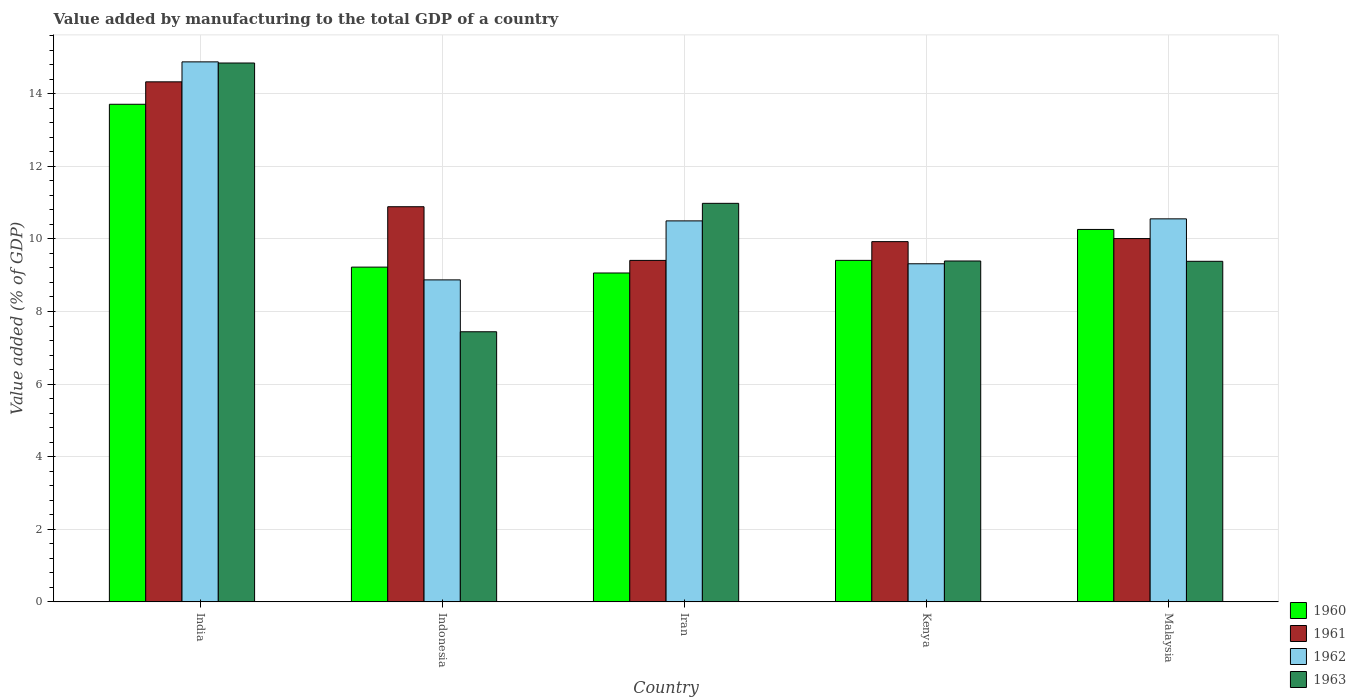How many groups of bars are there?
Offer a very short reply. 5. Are the number of bars on each tick of the X-axis equal?
Your answer should be very brief. Yes. How many bars are there on the 3rd tick from the right?
Ensure brevity in your answer.  4. What is the label of the 2nd group of bars from the left?
Offer a very short reply. Indonesia. In how many cases, is the number of bars for a given country not equal to the number of legend labels?
Offer a terse response. 0. What is the value added by manufacturing to the total GDP in 1961 in India?
Give a very brief answer. 14.33. Across all countries, what is the maximum value added by manufacturing to the total GDP in 1962?
Your answer should be very brief. 14.88. Across all countries, what is the minimum value added by manufacturing to the total GDP in 1961?
Offer a terse response. 9.41. In which country was the value added by manufacturing to the total GDP in 1960 minimum?
Your response must be concise. Iran. What is the total value added by manufacturing to the total GDP in 1961 in the graph?
Give a very brief answer. 54.56. What is the difference between the value added by manufacturing to the total GDP in 1962 in Kenya and that in Malaysia?
Provide a succinct answer. -1.24. What is the difference between the value added by manufacturing to the total GDP in 1962 in India and the value added by manufacturing to the total GDP in 1963 in Indonesia?
Provide a short and direct response. 7.44. What is the average value added by manufacturing to the total GDP in 1962 per country?
Give a very brief answer. 10.82. What is the difference between the value added by manufacturing to the total GDP of/in 1962 and value added by manufacturing to the total GDP of/in 1961 in India?
Offer a terse response. 0.55. What is the ratio of the value added by manufacturing to the total GDP in 1960 in India to that in Iran?
Ensure brevity in your answer.  1.51. Is the difference between the value added by manufacturing to the total GDP in 1962 in Indonesia and Malaysia greater than the difference between the value added by manufacturing to the total GDP in 1961 in Indonesia and Malaysia?
Make the answer very short. No. What is the difference between the highest and the second highest value added by manufacturing to the total GDP in 1960?
Ensure brevity in your answer.  -0.85. What is the difference between the highest and the lowest value added by manufacturing to the total GDP in 1962?
Ensure brevity in your answer.  6.01. In how many countries, is the value added by manufacturing to the total GDP in 1963 greater than the average value added by manufacturing to the total GDP in 1963 taken over all countries?
Offer a terse response. 2. What does the 1st bar from the left in Kenya represents?
Provide a succinct answer. 1960. Is it the case that in every country, the sum of the value added by manufacturing to the total GDP in 1962 and value added by manufacturing to the total GDP in 1963 is greater than the value added by manufacturing to the total GDP in 1961?
Offer a very short reply. Yes. How many bars are there?
Provide a short and direct response. 20. Are the values on the major ticks of Y-axis written in scientific E-notation?
Keep it short and to the point. No. How many legend labels are there?
Make the answer very short. 4. How are the legend labels stacked?
Your answer should be very brief. Vertical. What is the title of the graph?
Ensure brevity in your answer.  Value added by manufacturing to the total GDP of a country. What is the label or title of the Y-axis?
Give a very brief answer. Value added (% of GDP). What is the Value added (% of GDP) in 1960 in India?
Ensure brevity in your answer.  13.71. What is the Value added (% of GDP) in 1961 in India?
Your answer should be very brief. 14.33. What is the Value added (% of GDP) of 1962 in India?
Your answer should be compact. 14.88. What is the Value added (% of GDP) of 1963 in India?
Your answer should be very brief. 14.85. What is the Value added (% of GDP) in 1960 in Indonesia?
Ensure brevity in your answer.  9.22. What is the Value added (% of GDP) of 1961 in Indonesia?
Provide a succinct answer. 10.89. What is the Value added (% of GDP) in 1962 in Indonesia?
Offer a very short reply. 8.87. What is the Value added (% of GDP) in 1963 in Indonesia?
Ensure brevity in your answer.  7.44. What is the Value added (% of GDP) in 1960 in Iran?
Keep it short and to the point. 9.06. What is the Value added (% of GDP) of 1961 in Iran?
Your answer should be very brief. 9.41. What is the Value added (% of GDP) of 1962 in Iran?
Your answer should be compact. 10.5. What is the Value added (% of GDP) in 1963 in Iran?
Provide a short and direct response. 10.98. What is the Value added (% of GDP) in 1960 in Kenya?
Offer a terse response. 9.41. What is the Value added (% of GDP) of 1961 in Kenya?
Keep it short and to the point. 9.93. What is the Value added (% of GDP) of 1962 in Kenya?
Offer a terse response. 9.32. What is the Value added (% of GDP) of 1963 in Kenya?
Provide a short and direct response. 9.39. What is the Value added (% of GDP) in 1960 in Malaysia?
Provide a succinct answer. 10.26. What is the Value added (% of GDP) in 1961 in Malaysia?
Provide a short and direct response. 10.01. What is the Value added (% of GDP) in 1962 in Malaysia?
Provide a short and direct response. 10.55. What is the Value added (% of GDP) of 1963 in Malaysia?
Provide a short and direct response. 9.38. Across all countries, what is the maximum Value added (% of GDP) in 1960?
Make the answer very short. 13.71. Across all countries, what is the maximum Value added (% of GDP) in 1961?
Keep it short and to the point. 14.33. Across all countries, what is the maximum Value added (% of GDP) in 1962?
Make the answer very short. 14.88. Across all countries, what is the maximum Value added (% of GDP) in 1963?
Provide a succinct answer. 14.85. Across all countries, what is the minimum Value added (% of GDP) in 1960?
Your answer should be very brief. 9.06. Across all countries, what is the minimum Value added (% of GDP) in 1961?
Your answer should be very brief. 9.41. Across all countries, what is the minimum Value added (% of GDP) of 1962?
Your answer should be very brief. 8.87. Across all countries, what is the minimum Value added (% of GDP) in 1963?
Ensure brevity in your answer.  7.44. What is the total Value added (% of GDP) in 1960 in the graph?
Your answer should be compact. 51.66. What is the total Value added (% of GDP) in 1961 in the graph?
Your answer should be very brief. 54.56. What is the total Value added (% of GDP) of 1962 in the graph?
Offer a very short reply. 54.11. What is the total Value added (% of GDP) in 1963 in the graph?
Ensure brevity in your answer.  52.04. What is the difference between the Value added (% of GDP) of 1960 in India and that in Indonesia?
Ensure brevity in your answer.  4.49. What is the difference between the Value added (% of GDP) of 1961 in India and that in Indonesia?
Your response must be concise. 3.44. What is the difference between the Value added (% of GDP) of 1962 in India and that in Indonesia?
Provide a short and direct response. 6.01. What is the difference between the Value added (% of GDP) in 1963 in India and that in Indonesia?
Offer a terse response. 7.4. What is the difference between the Value added (% of GDP) in 1960 in India and that in Iran?
Your answer should be very brief. 4.65. What is the difference between the Value added (% of GDP) in 1961 in India and that in Iran?
Your answer should be compact. 4.92. What is the difference between the Value added (% of GDP) in 1962 in India and that in Iran?
Provide a short and direct response. 4.38. What is the difference between the Value added (% of GDP) in 1963 in India and that in Iran?
Ensure brevity in your answer.  3.87. What is the difference between the Value added (% of GDP) of 1960 in India and that in Kenya?
Give a very brief answer. 4.3. What is the difference between the Value added (% of GDP) in 1961 in India and that in Kenya?
Offer a very short reply. 4.4. What is the difference between the Value added (% of GDP) in 1962 in India and that in Kenya?
Your answer should be compact. 5.56. What is the difference between the Value added (% of GDP) of 1963 in India and that in Kenya?
Provide a succinct answer. 5.45. What is the difference between the Value added (% of GDP) in 1960 in India and that in Malaysia?
Make the answer very short. 3.45. What is the difference between the Value added (% of GDP) of 1961 in India and that in Malaysia?
Make the answer very short. 4.32. What is the difference between the Value added (% of GDP) in 1962 in India and that in Malaysia?
Make the answer very short. 4.33. What is the difference between the Value added (% of GDP) in 1963 in India and that in Malaysia?
Your answer should be very brief. 5.46. What is the difference between the Value added (% of GDP) of 1960 in Indonesia and that in Iran?
Offer a very short reply. 0.16. What is the difference between the Value added (% of GDP) in 1961 in Indonesia and that in Iran?
Offer a very short reply. 1.48. What is the difference between the Value added (% of GDP) in 1962 in Indonesia and that in Iran?
Your answer should be very brief. -1.63. What is the difference between the Value added (% of GDP) of 1963 in Indonesia and that in Iran?
Keep it short and to the point. -3.54. What is the difference between the Value added (% of GDP) in 1960 in Indonesia and that in Kenya?
Offer a terse response. -0.19. What is the difference between the Value added (% of GDP) of 1961 in Indonesia and that in Kenya?
Offer a terse response. 0.96. What is the difference between the Value added (% of GDP) of 1962 in Indonesia and that in Kenya?
Make the answer very short. -0.44. What is the difference between the Value added (% of GDP) in 1963 in Indonesia and that in Kenya?
Make the answer very short. -1.95. What is the difference between the Value added (% of GDP) in 1960 in Indonesia and that in Malaysia?
Give a very brief answer. -1.04. What is the difference between the Value added (% of GDP) of 1961 in Indonesia and that in Malaysia?
Your answer should be very brief. 0.88. What is the difference between the Value added (% of GDP) of 1962 in Indonesia and that in Malaysia?
Offer a very short reply. -1.68. What is the difference between the Value added (% of GDP) in 1963 in Indonesia and that in Malaysia?
Provide a short and direct response. -1.94. What is the difference between the Value added (% of GDP) of 1960 in Iran and that in Kenya?
Offer a very short reply. -0.35. What is the difference between the Value added (% of GDP) of 1961 in Iran and that in Kenya?
Your answer should be very brief. -0.52. What is the difference between the Value added (% of GDP) of 1962 in Iran and that in Kenya?
Keep it short and to the point. 1.18. What is the difference between the Value added (% of GDP) of 1963 in Iran and that in Kenya?
Offer a terse response. 1.59. What is the difference between the Value added (% of GDP) in 1960 in Iran and that in Malaysia?
Offer a very short reply. -1.2. What is the difference between the Value added (% of GDP) of 1961 in Iran and that in Malaysia?
Your answer should be very brief. -0.6. What is the difference between the Value added (% of GDP) of 1962 in Iran and that in Malaysia?
Provide a short and direct response. -0.06. What is the difference between the Value added (% of GDP) of 1963 in Iran and that in Malaysia?
Provide a succinct answer. 1.6. What is the difference between the Value added (% of GDP) in 1960 in Kenya and that in Malaysia?
Provide a short and direct response. -0.85. What is the difference between the Value added (% of GDP) of 1961 in Kenya and that in Malaysia?
Provide a short and direct response. -0.08. What is the difference between the Value added (% of GDP) of 1962 in Kenya and that in Malaysia?
Your response must be concise. -1.24. What is the difference between the Value added (% of GDP) of 1963 in Kenya and that in Malaysia?
Ensure brevity in your answer.  0.01. What is the difference between the Value added (% of GDP) in 1960 in India and the Value added (% of GDP) in 1961 in Indonesia?
Offer a terse response. 2.82. What is the difference between the Value added (% of GDP) of 1960 in India and the Value added (% of GDP) of 1962 in Indonesia?
Make the answer very short. 4.84. What is the difference between the Value added (% of GDP) in 1960 in India and the Value added (% of GDP) in 1963 in Indonesia?
Your response must be concise. 6.27. What is the difference between the Value added (% of GDP) in 1961 in India and the Value added (% of GDP) in 1962 in Indonesia?
Provide a short and direct response. 5.46. What is the difference between the Value added (% of GDP) in 1961 in India and the Value added (% of GDP) in 1963 in Indonesia?
Keep it short and to the point. 6.89. What is the difference between the Value added (% of GDP) in 1962 in India and the Value added (% of GDP) in 1963 in Indonesia?
Make the answer very short. 7.44. What is the difference between the Value added (% of GDP) of 1960 in India and the Value added (% of GDP) of 1961 in Iran?
Provide a short and direct response. 4.3. What is the difference between the Value added (% of GDP) in 1960 in India and the Value added (% of GDP) in 1962 in Iran?
Your answer should be very brief. 3.21. What is the difference between the Value added (% of GDP) of 1960 in India and the Value added (% of GDP) of 1963 in Iran?
Ensure brevity in your answer.  2.73. What is the difference between the Value added (% of GDP) in 1961 in India and the Value added (% of GDP) in 1962 in Iran?
Make the answer very short. 3.83. What is the difference between the Value added (% of GDP) in 1961 in India and the Value added (% of GDP) in 1963 in Iran?
Offer a very short reply. 3.35. What is the difference between the Value added (% of GDP) in 1962 in India and the Value added (% of GDP) in 1963 in Iran?
Keep it short and to the point. 3.9. What is the difference between the Value added (% of GDP) of 1960 in India and the Value added (% of GDP) of 1961 in Kenya?
Offer a very short reply. 3.78. What is the difference between the Value added (% of GDP) in 1960 in India and the Value added (% of GDP) in 1962 in Kenya?
Keep it short and to the point. 4.39. What is the difference between the Value added (% of GDP) of 1960 in India and the Value added (% of GDP) of 1963 in Kenya?
Your answer should be very brief. 4.32. What is the difference between the Value added (% of GDP) of 1961 in India and the Value added (% of GDP) of 1962 in Kenya?
Provide a short and direct response. 5.01. What is the difference between the Value added (% of GDP) of 1961 in India and the Value added (% of GDP) of 1963 in Kenya?
Provide a succinct answer. 4.94. What is the difference between the Value added (% of GDP) of 1962 in India and the Value added (% of GDP) of 1963 in Kenya?
Provide a short and direct response. 5.49. What is the difference between the Value added (% of GDP) in 1960 in India and the Value added (% of GDP) in 1961 in Malaysia?
Offer a very short reply. 3.7. What is the difference between the Value added (% of GDP) in 1960 in India and the Value added (% of GDP) in 1962 in Malaysia?
Provide a succinct answer. 3.16. What is the difference between the Value added (% of GDP) of 1960 in India and the Value added (% of GDP) of 1963 in Malaysia?
Your response must be concise. 4.33. What is the difference between the Value added (% of GDP) in 1961 in India and the Value added (% of GDP) in 1962 in Malaysia?
Keep it short and to the point. 3.78. What is the difference between the Value added (% of GDP) of 1961 in India and the Value added (% of GDP) of 1963 in Malaysia?
Keep it short and to the point. 4.94. What is the difference between the Value added (% of GDP) of 1962 in India and the Value added (% of GDP) of 1963 in Malaysia?
Offer a terse response. 5.49. What is the difference between the Value added (% of GDP) of 1960 in Indonesia and the Value added (% of GDP) of 1961 in Iran?
Your response must be concise. -0.18. What is the difference between the Value added (% of GDP) in 1960 in Indonesia and the Value added (% of GDP) in 1962 in Iran?
Ensure brevity in your answer.  -1.27. What is the difference between the Value added (% of GDP) in 1960 in Indonesia and the Value added (% of GDP) in 1963 in Iran?
Your answer should be compact. -1.76. What is the difference between the Value added (% of GDP) of 1961 in Indonesia and the Value added (% of GDP) of 1962 in Iran?
Keep it short and to the point. 0.39. What is the difference between the Value added (% of GDP) of 1961 in Indonesia and the Value added (% of GDP) of 1963 in Iran?
Offer a terse response. -0.09. What is the difference between the Value added (% of GDP) in 1962 in Indonesia and the Value added (% of GDP) in 1963 in Iran?
Provide a succinct answer. -2.11. What is the difference between the Value added (% of GDP) in 1960 in Indonesia and the Value added (% of GDP) in 1961 in Kenya?
Give a very brief answer. -0.7. What is the difference between the Value added (% of GDP) of 1960 in Indonesia and the Value added (% of GDP) of 1962 in Kenya?
Your response must be concise. -0.09. What is the difference between the Value added (% of GDP) in 1960 in Indonesia and the Value added (% of GDP) in 1963 in Kenya?
Your answer should be very brief. -0.17. What is the difference between the Value added (% of GDP) of 1961 in Indonesia and the Value added (% of GDP) of 1962 in Kenya?
Offer a terse response. 1.57. What is the difference between the Value added (% of GDP) in 1961 in Indonesia and the Value added (% of GDP) in 1963 in Kenya?
Make the answer very short. 1.5. What is the difference between the Value added (% of GDP) in 1962 in Indonesia and the Value added (% of GDP) in 1963 in Kenya?
Provide a succinct answer. -0.52. What is the difference between the Value added (% of GDP) in 1960 in Indonesia and the Value added (% of GDP) in 1961 in Malaysia?
Keep it short and to the point. -0.79. What is the difference between the Value added (% of GDP) of 1960 in Indonesia and the Value added (% of GDP) of 1962 in Malaysia?
Give a very brief answer. -1.33. What is the difference between the Value added (% of GDP) in 1960 in Indonesia and the Value added (% of GDP) in 1963 in Malaysia?
Offer a very short reply. -0.16. What is the difference between the Value added (% of GDP) in 1961 in Indonesia and the Value added (% of GDP) in 1962 in Malaysia?
Provide a succinct answer. 0.33. What is the difference between the Value added (% of GDP) of 1961 in Indonesia and the Value added (% of GDP) of 1963 in Malaysia?
Offer a terse response. 1.5. What is the difference between the Value added (% of GDP) in 1962 in Indonesia and the Value added (% of GDP) in 1963 in Malaysia?
Offer a terse response. -0.51. What is the difference between the Value added (% of GDP) in 1960 in Iran and the Value added (% of GDP) in 1961 in Kenya?
Provide a succinct answer. -0.86. What is the difference between the Value added (% of GDP) of 1960 in Iran and the Value added (% of GDP) of 1962 in Kenya?
Keep it short and to the point. -0.25. What is the difference between the Value added (% of GDP) of 1960 in Iran and the Value added (% of GDP) of 1963 in Kenya?
Offer a terse response. -0.33. What is the difference between the Value added (% of GDP) of 1961 in Iran and the Value added (% of GDP) of 1962 in Kenya?
Offer a very short reply. 0.09. What is the difference between the Value added (% of GDP) of 1961 in Iran and the Value added (% of GDP) of 1963 in Kenya?
Your response must be concise. 0.02. What is the difference between the Value added (% of GDP) of 1962 in Iran and the Value added (% of GDP) of 1963 in Kenya?
Your answer should be very brief. 1.11. What is the difference between the Value added (% of GDP) in 1960 in Iran and the Value added (% of GDP) in 1961 in Malaysia?
Provide a succinct answer. -0.95. What is the difference between the Value added (% of GDP) of 1960 in Iran and the Value added (% of GDP) of 1962 in Malaysia?
Offer a very short reply. -1.49. What is the difference between the Value added (% of GDP) of 1960 in Iran and the Value added (% of GDP) of 1963 in Malaysia?
Give a very brief answer. -0.32. What is the difference between the Value added (% of GDP) of 1961 in Iran and the Value added (% of GDP) of 1962 in Malaysia?
Your answer should be very brief. -1.14. What is the difference between the Value added (% of GDP) of 1961 in Iran and the Value added (% of GDP) of 1963 in Malaysia?
Give a very brief answer. 0.03. What is the difference between the Value added (% of GDP) in 1962 in Iran and the Value added (% of GDP) in 1963 in Malaysia?
Make the answer very short. 1.11. What is the difference between the Value added (% of GDP) of 1960 in Kenya and the Value added (% of GDP) of 1961 in Malaysia?
Make the answer very short. -0.6. What is the difference between the Value added (% of GDP) in 1960 in Kenya and the Value added (% of GDP) in 1962 in Malaysia?
Your answer should be compact. -1.14. What is the difference between the Value added (% of GDP) of 1960 in Kenya and the Value added (% of GDP) of 1963 in Malaysia?
Make the answer very short. 0.03. What is the difference between the Value added (% of GDP) of 1961 in Kenya and the Value added (% of GDP) of 1962 in Malaysia?
Offer a terse response. -0.63. What is the difference between the Value added (% of GDP) of 1961 in Kenya and the Value added (% of GDP) of 1963 in Malaysia?
Give a very brief answer. 0.54. What is the difference between the Value added (% of GDP) of 1962 in Kenya and the Value added (% of GDP) of 1963 in Malaysia?
Offer a very short reply. -0.07. What is the average Value added (% of GDP) in 1960 per country?
Provide a succinct answer. 10.33. What is the average Value added (% of GDP) of 1961 per country?
Make the answer very short. 10.91. What is the average Value added (% of GDP) in 1962 per country?
Provide a short and direct response. 10.82. What is the average Value added (% of GDP) of 1963 per country?
Make the answer very short. 10.41. What is the difference between the Value added (% of GDP) in 1960 and Value added (% of GDP) in 1961 in India?
Ensure brevity in your answer.  -0.62. What is the difference between the Value added (% of GDP) of 1960 and Value added (% of GDP) of 1962 in India?
Make the answer very short. -1.17. What is the difference between the Value added (% of GDP) in 1960 and Value added (% of GDP) in 1963 in India?
Provide a short and direct response. -1.14. What is the difference between the Value added (% of GDP) of 1961 and Value added (% of GDP) of 1962 in India?
Offer a terse response. -0.55. What is the difference between the Value added (% of GDP) in 1961 and Value added (% of GDP) in 1963 in India?
Your answer should be very brief. -0.52. What is the difference between the Value added (% of GDP) in 1962 and Value added (% of GDP) in 1963 in India?
Your answer should be compact. 0.03. What is the difference between the Value added (% of GDP) in 1960 and Value added (% of GDP) in 1961 in Indonesia?
Offer a very short reply. -1.66. What is the difference between the Value added (% of GDP) of 1960 and Value added (% of GDP) of 1962 in Indonesia?
Provide a succinct answer. 0.35. What is the difference between the Value added (% of GDP) of 1960 and Value added (% of GDP) of 1963 in Indonesia?
Make the answer very short. 1.78. What is the difference between the Value added (% of GDP) in 1961 and Value added (% of GDP) in 1962 in Indonesia?
Provide a succinct answer. 2.02. What is the difference between the Value added (% of GDP) in 1961 and Value added (% of GDP) in 1963 in Indonesia?
Your answer should be compact. 3.44. What is the difference between the Value added (% of GDP) in 1962 and Value added (% of GDP) in 1963 in Indonesia?
Keep it short and to the point. 1.43. What is the difference between the Value added (% of GDP) of 1960 and Value added (% of GDP) of 1961 in Iran?
Your answer should be very brief. -0.35. What is the difference between the Value added (% of GDP) of 1960 and Value added (% of GDP) of 1962 in Iran?
Your response must be concise. -1.44. What is the difference between the Value added (% of GDP) in 1960 and Value added (% of GDP) in 1963 in Iran?
Your answer should be compact. -1.92. What is the difference between the Value added (% of GDP) of 1961 and Value added (% of GDP) of 1962 in Iran?
Your response must be concise. -1.09. What is the difference between the Value added (% of GDP) in 1961 and Value added (% of GDP) in 1963 in Iran?
Ensure brevity in your answer.  -1.57. What is the difference between the Value added (% of GDP) of 1962 and Value added (% of GDP) of 1963 in Iran?
Offer a very short reply. -0.48. What is the difference between the Value added (% of GDP) of 1960 and Value added (% of GDP) of 1961 in Kenya?
Provide a succinct answer. -0.52. What is the difference between the Value added (% of GDP) in 1960 and Value added (% of GDP) in 1962 in Kenya?
Keep it short and to the point. 0.09. What is the difference between the Value added (% of GDP) in 1960 and Value added (% of GDP) in 1963 in Kenya?
Provide a short and direct response. 0.02. What is the difference between the Value added (% of GDP) of 1961 and Value added (% of GDP) of 1962 in Kenya?
Your response must be concise. 0.61. What is the difference between the Value added (% of GDP) of 1961 and Value added (% of GDP) of 1963 in Kenya?
Give a very brief answer. 0.53. What is the difference between the Value added (% of GDP) of 1962 and Value added (% of GDP) of 1963 in Kenya?
Provide a succinct answer. -0.08. What is the difference between the Value added (% of GDP) of 1960 and Value added (% of GDP) of 1961 in Malaysia?
Your answer should be very brief. 0.25. What is the difference between the Value added (% of GDP) of 1960 and Value added (% of GDP) of 1962 in Malaysia?
Your answer should be compact. -0.29. What is the difference between the Value added (% of GDP) of 1960 and Value added (% of GDP) of 1963 in Malaysia?
Make the answer very short. 0.88. What is the difference between the Value added (% of GDP) in 1961 and Value added (% of GDP) in 1962 in Malaysia?
Provide a short and direct response. -0.54. What is the difference between the Value added (% of GDP) of 1961 and Value added (% of GDP) of 1963 in Malaysia?
Ensure brevity in your answer.  0.63. What is the difference between the Value added (% of GDP) of 1962 and Value added (% of GDP) of 1963 in Malaysia?
Give a very brief answer. 1.17. What is the ratio of the Value added (% of GDP) of 1960 in India to that in Indonesia?
Your answer should be compact. 1.49. What is the ratio of the Value added (% of GDP) of 1961 in India to that in Indonesia?
Keep it short and to the point. 1.32. What is the ratio of the Value added (% of GDP) in 1962 in India to that in Indonesia?
Provide a short and direct response. 1.68. What is the ratio of the Value added (% of GDP) in 1963 in India to that in Indonesia?
Your response must be concise. 1.99. What is the ratio of the Value added (% of GDP) of 1960 in India to that in Iran?
Provide a succinct answer. 1.51. What is the ratio of the Value added (% of GDP) of 1961 in India to that in Iran?
Your answer should be compact. 1.52. What is the ratio of the Value added (% of GDP) in 1962 in India to that in Iran?
Provide a short and direct response. 1.42. What is the ratio of the Value added (% of GDP) of 1963 in India to that in Iran?
Your answer should be very brief. 1.35. What is the ratio of the Value added (% of GDP) of 1960 in India to that in Kenya?
Offer a terse response. 1.46. What is the ratio of the Value added (% of GDP) in 1961 in India to that in Kenya?
Keep it short and to the point. 1.44. What is the ratio of the Value added (% of GDP) of 1962 in India to that in Kenya?
Offer a terse response. 1.6. What is the ratio of the Value added (% of GDP) in 1963 in India to that in Kenya?
Your response must be concise. 1.58. What is the ratio of the Value added (% of GDP) in 1960 in India to that in Malaysia?
Give a very brief answer. 1.34. What is the ratio of the Value added (% of GDP) in 1961 in India to that in Malaysia?
Keep it short and to the point. 1.43. What is the ratio of the Value added (% of GDP) of 1962 in India to that in Malaysia?
Your answer should be very brief. 1.41. What is the ratio of the Value added (% of GDP) in 1963 in India to that in Malaysia?
Keep it short and to the point. 1.58. What is the ratio of the Value added (% of GDP) of 1960 in Indonesia to that in Iran?
Keep it short and to the point. 1.02. What is the ratio of the Value added (% of GDP) in 1961 in Indonesia to that in Iran?
Your response must be concise. 1.16. What is the ratio of the Value added (% of GDP) of 1962 in Indonesia to that in Iran?
Offer a terse response. 0.85. What is the ratio of the Value added (% of GDP) of 1963 in Indonesia to that in Iran?
Keep it short and to the point. 0.68. What is the ratio of the Value added (% of GDP) of 1960 in Indonesia to that in Kenya?
Your response must be concise. 0.98. What is the ratio of the Value added (% of GDP) in 1961 in Indonesia to that in Kenya?
Your response must be concise. 1.1. What is the ratio of the Value added (% of GDP) in 1962 in Indonesia to that in Kenya?
Provide a succinct answer. 0.95. What is the ratio of the Value added (% of GDP) of 1963 in Indonesia to that in Kenya?
Make the answer very short. 0.79. What is the ratio of the Value added (% of GDP) of 1960 in Indonesia to that in Malaysia?
Make the answer very short. 0.9. What is the ratio of the Value added (% of GDP) in 1961 in Indonesia to that in Malaysia?
Make the answer very short. 1.09. What is the ratio of the Value added (% of GDP) of 1962 in Indonesia to that in Malaysia?
Keep it short and to the point. 0.84. What is the ratio of the Value added (% of GDP) in 1963 in Indonesia to that in Malaysia?
Your response must be concise. 0.79. What is the ratio of the Value added (% of GDP) of 1960 in Iran to that in Kenya?
Make the answer very short. 0.96. What is the ratio of the Value added (% of GDP) of 1961 in Iran to that in Kenya?
Offer a very short reply. 0.95. What is the ratio of the Value added (% of GDP) of 1962 in Iran to that in Kenya?
Your response must be concise. 1.13. What is the ratio of the Value added (% of GDP) of 1963 in Iran to that in Kenya?
Your response must be concise. 1.17. What is the ratio of the Value added (% of GDP) in 1960 in Iran to that in Malaysia?
Offer a very short reply. 0.88. What is the ratio of the Value added (% of GDP) of 1961 in Iran to that in Malaysia?
Ensure brevity in your answer.  0.94. What is the ratio of the Value added (% of GDP) in 1962 in Iran to that in Malaysia?
Your answer should be compact. 0.99. What is the ratio of the Value added (% of GDP) in 1963 in Iran to that in Malaysia?
Your response must be concise. 1.17. What is the ratio of the Value added (% of GDP) in 1960 in Kenya to that in Malaysia?
Offer a terse response. 0.92. What is the ratio of the Value added (% of GDP) of 1962 in Kenya to that in Malaysia?
Offer a terse response. 0.88. What is the ratio of the Value added (% of GDP) in 1963 in Kenya to that in Malaysia?
Ensure brevity in your answer.  1. What is the difference between the highest and the second highest Value added (% of GDP) in 1960?
Your answer should be very brief. 3.45. What is the difference between the highest and the second highest Value added (% of GDP) of 1961?
Keep it short and to the point. 3.44. What is the difference between the highest and the second highest Value added (% of GDP) in 1962?
Keep it short and to the point. 4.33. What is the difference between the highest and the second highest Value added (% of GDP) of 1963?
Ensure brevity in your answer.  3.87. What is the difference between the highest and the lowest Value added (% of GDP) of 1960?
Provide a short and direct response. 4.65. What is the difference between the highest and the lowest Value added (% of GDP) of 1961?
Ensure brevity in your answer.  4.92. What is the difference between the highest and the lowest Value added (% of GDP) of 1962?
Your answer should be compact. 6.01. What is the difference between the highest and the lowest Value added (% of GDP) of 1963?
Keep it short and to the point. 7.4. 